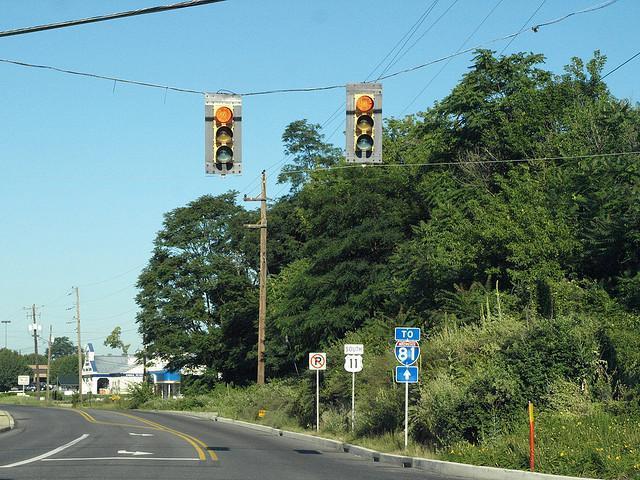How many power poles are visible?
Give a very brief answer. 3. How many boats are in the photo?
Give a very brief answer. 0. 